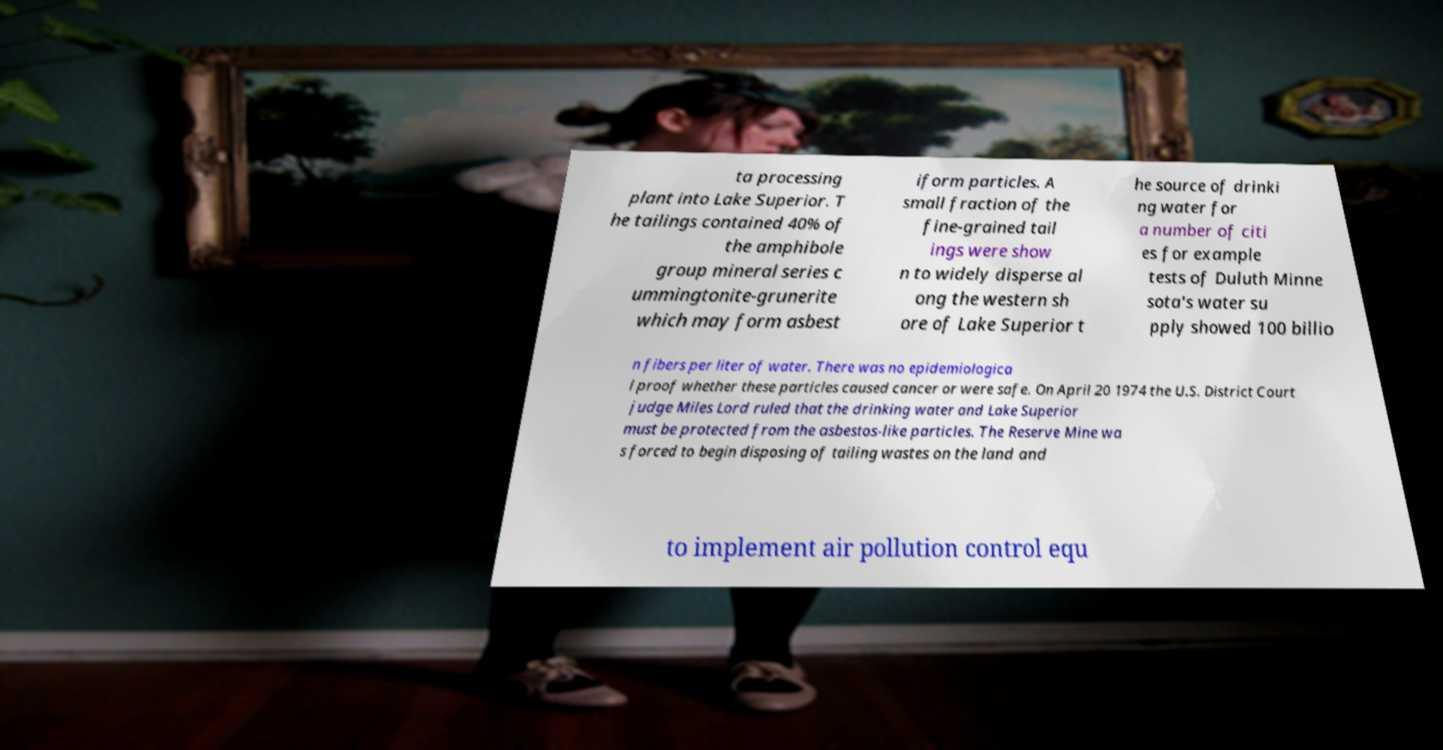What messages or text are displayed in this image? I need them in a readable, typed format. ta processing plant into Lake Superior. T he tailings contained 40% of the amphibole group mineral series c ummingtonite-grunerite which may form asbest iform particles. A small fraction of the fine-grained tail ings were show n to widely disperse al ong the western sh ore of Lake Superior t he source of drinki ng water for a number of citi es for example tests of Duluth Minne sota's water su pply showed 100 billio n fibers per liter of water. There was no epidemiologica l proof whether these particles caused cancer or were safe. On April 20 1974 the U.S. District Court judge Miles Lord ruled that the drinking water and Lake Superior must be protected from the asbestos-like particles. The Reserve Mine wa s forced to begin disposing of tailing wastes on the land and to implement air pollution control equ 